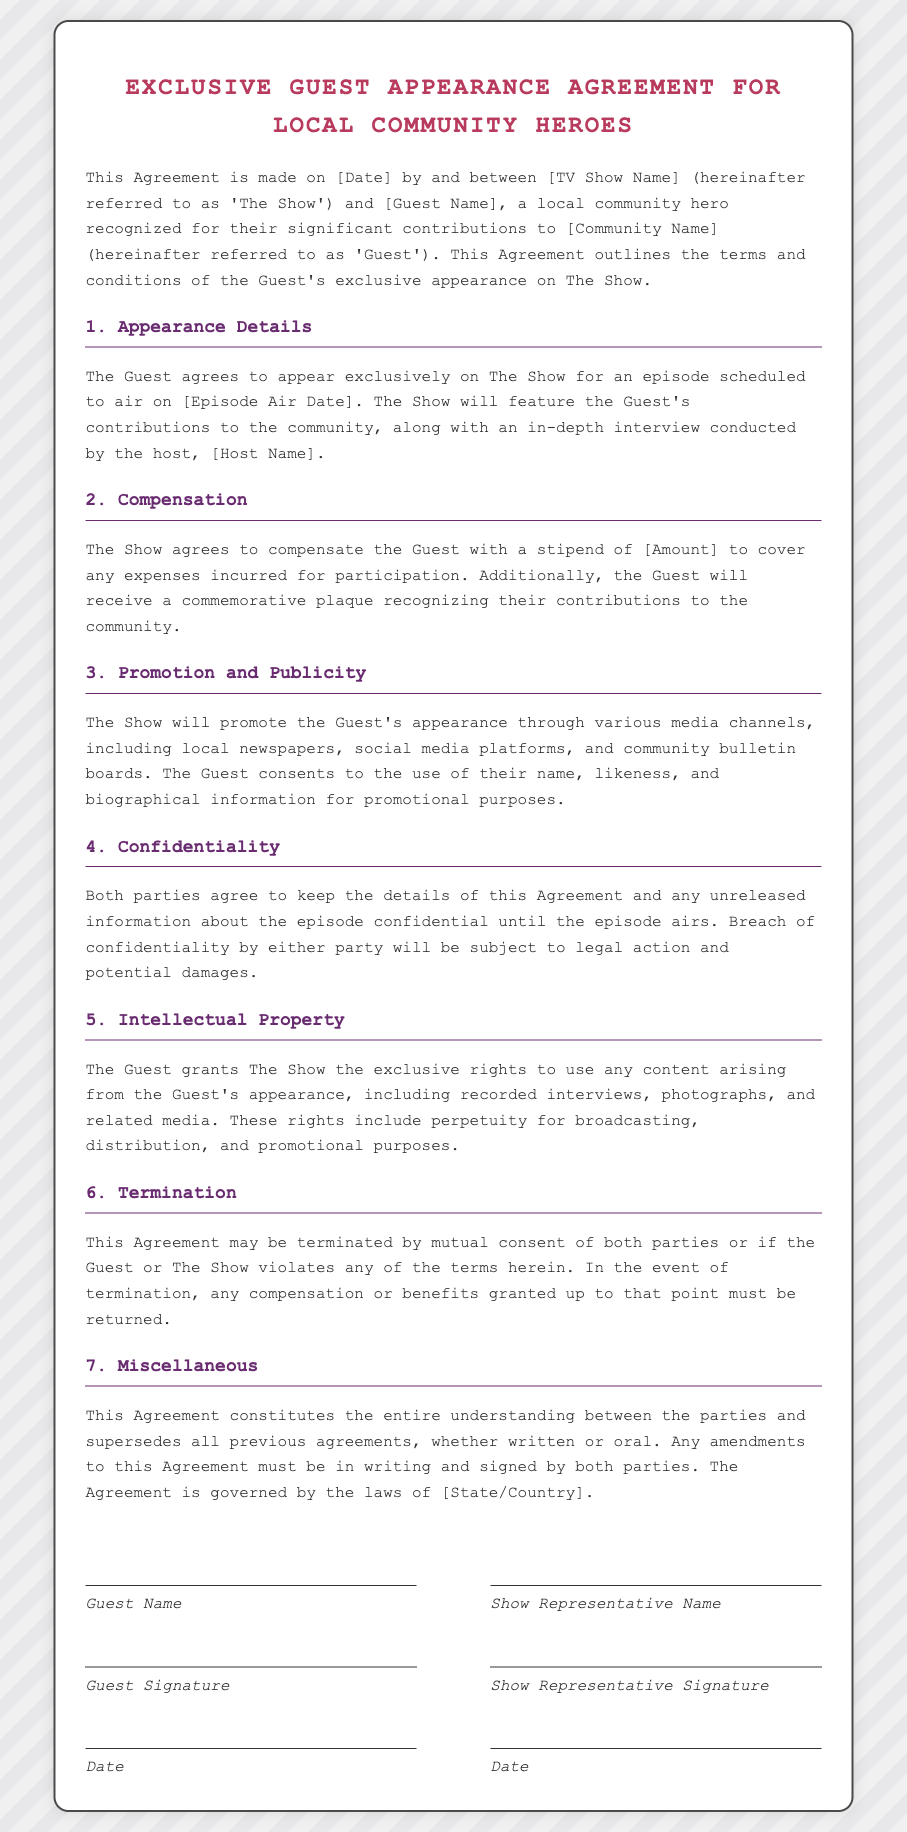what is the date of the agreement? The date of the agreement is specified in the placeholder [Date].
Answer: [Date] who is the guest recognized for their contributions? The guest is referred to as [Guest Name], a local community hero.
Answer: [Guest Name] what is the stipend amount for the guest's appearance? The stipend amount is specified in the placeholder [Amount].
Answer: [Amount] which community is being recognized in this agreement? The community is referred to as [Community Name].
Answer: [Community Name] who will conduct the in-depth interview? The interview will be conducted by [Host Name].
Answer: [Host Name] what rights does the guest grant to the show regarding content? The guest grants The Show exclusive rights to use recorded interviews, photographs, and related media.
Answer: exclusive rights how can this agreement be terminated? This agreement may be terminated by mutual consent or violations of terms.
Answer: mutual consent or violations what must be done for any amendments to the agreement? Any amendments must be in writing and signed by both parties.
Answer: in writing and signed which legal jurisdiction governs this agreement? The agreement is governed by the laws of [State/Country].
Answer: [State/Country] 